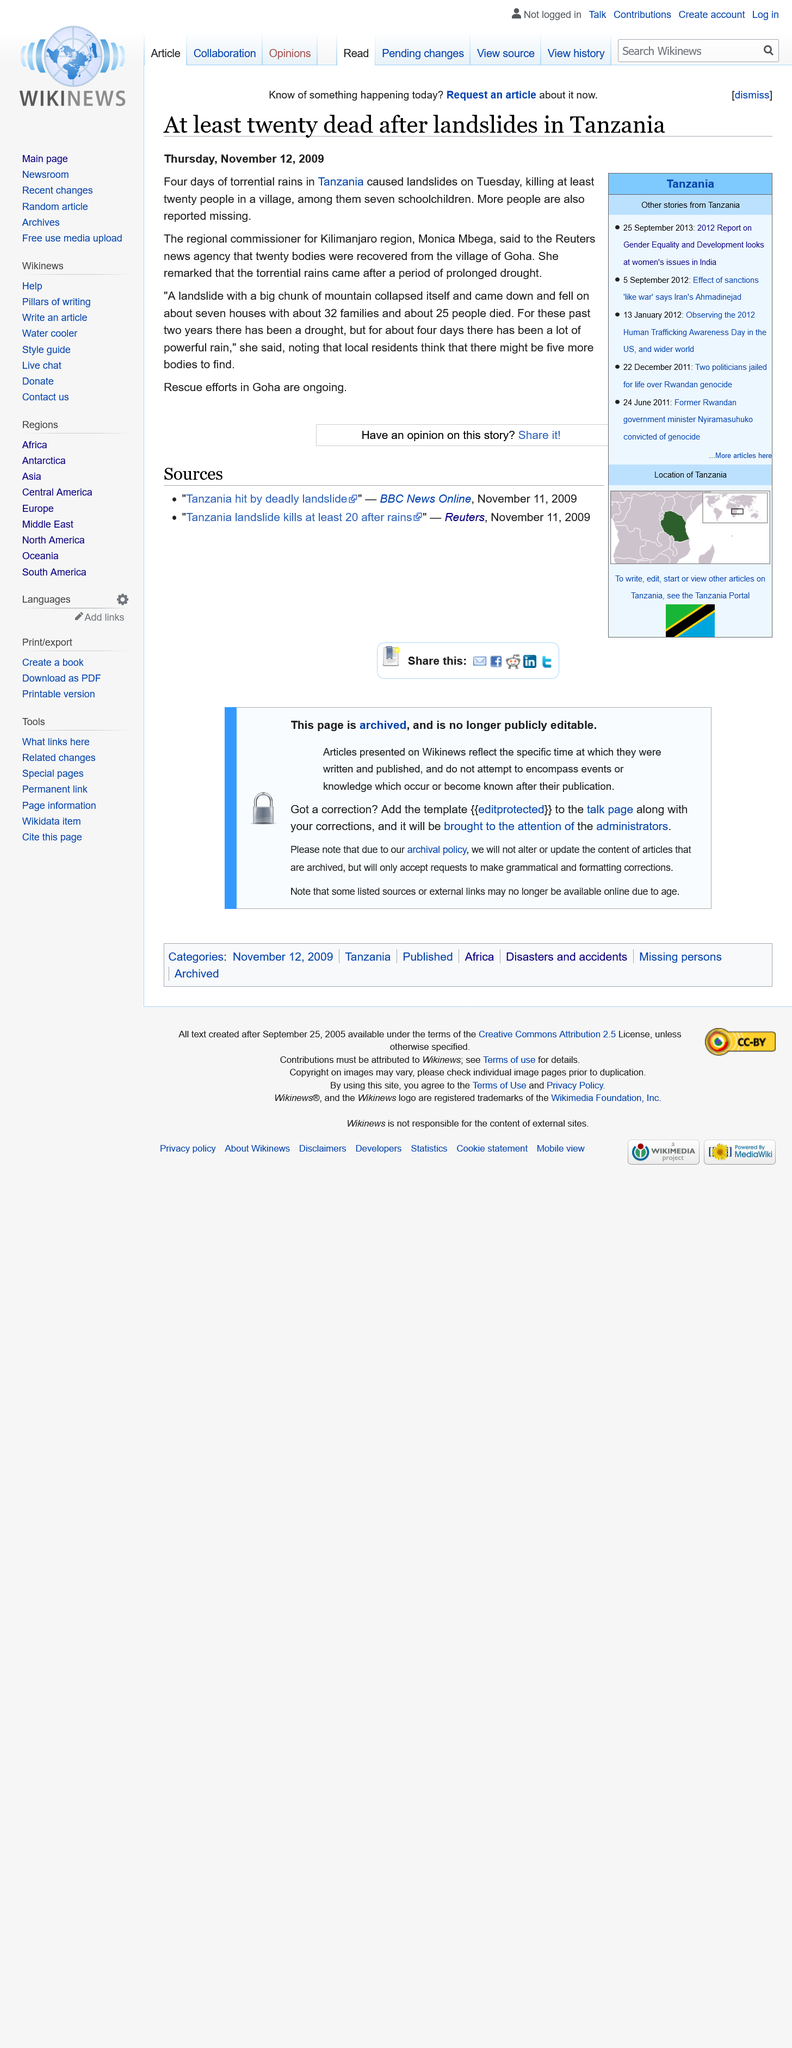Draw attention to some important aspects in this diagram. The landslide occurred in Tanzania. I published my article on December 11, 2009. At least 20 people died in landslides in Tanzania in November 2009. 